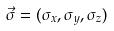Convert formula to latex. <formula><loc_0><loc_0><loc_500><loc_500>\vec { \sigma } = ( \sigma _ { x } , \sigma _ { y } , \sigma _ { z } )</formula> 